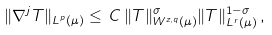Convert formula to latex. <formula><loc_0><loc_0><loc_500><loc_500>\| \nabla ^ { j } T \| _ { L ^ { p } { ( \mu ) } } \leq \, C \, \| T \| _ { W ^ { z , q } { ( \mu ) } } ^ { \sigma } \| T \| _ { L ^ { r } { ( \mu ) } } ^ { 1 - \sigma } \, ,</formula> 